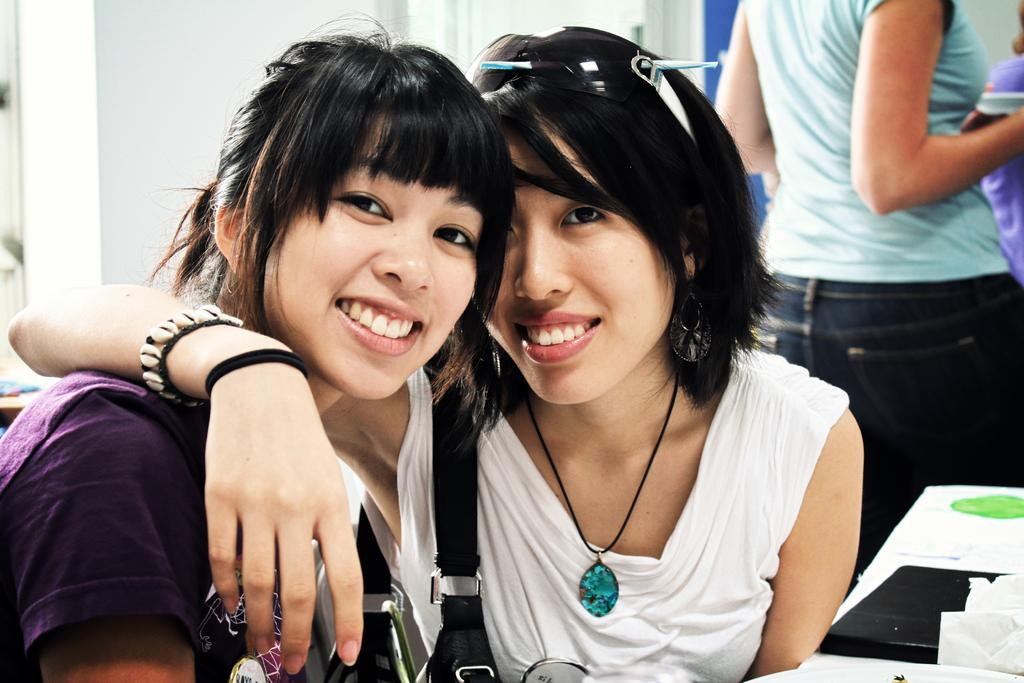How many women are present in the image? There are two women sitting in the image. What is the facial expression of the women? The women are smiling. What is placed in front of the women? There is a plate and tissue paper in front of the women. What can be seen on the table? There are objects on the table. What is visible in the background of the image? There are people and a wall in the background of the image. What type of can is visible on the table in the image? There is no can visible on the table in the image. What kind of patch is being sewn by the women in the image? The women are not sewing any patch in the image; they are simply sitting and smiling. 